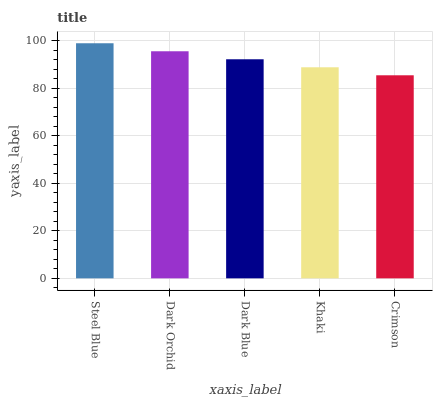Is Crimson the minimum?
Answer yes or no. Yes. Is Steel Blue the maximum?
Answer yes or no. Yes. Is Dark Orchid the minimum?
Answer yes or no. No. Is Dark Orchid the maximum?
Answer yes or no. No. Is Steel Blue greater than Dark Orchid?
Answer yes or no. Yes. Is Dark Orchid less than Steel Blue?
Answer yes or no. Yes. Is Dark Orchid greater than Steel Blue?
Answer yes or no. No. Is Steel Blue less than Dark Orchid?
Answer yes or no. No. Is Dark Blue the high median?
Answer yes or no. Yes. Is Dark Blue the low median?
Answer yes or no. Yes. Is Crimson the high median?
Answer yes or no. No. Is Steel Blue the low median?
Answer yes or no. No. 